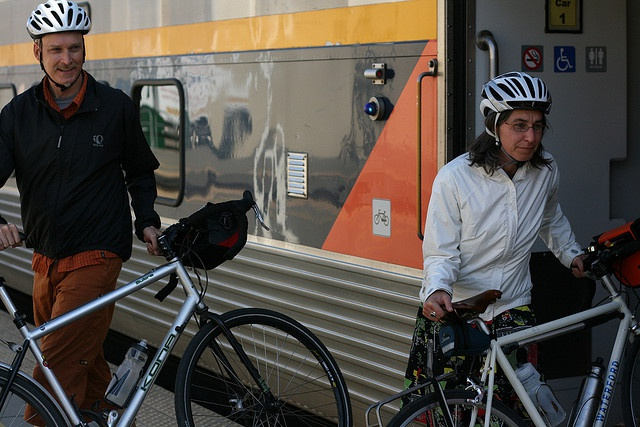Describe the objects in this image and their specific colors. I can see train in darkgray, gray, black, and tan tones, bicycle in darkgray, black, and gray tones, people in darkgray, black, maroon, gray, and brown tones, people in darkgray, black, and gray tones, and bicycle in darkgray, black, and gray tones in this image. 